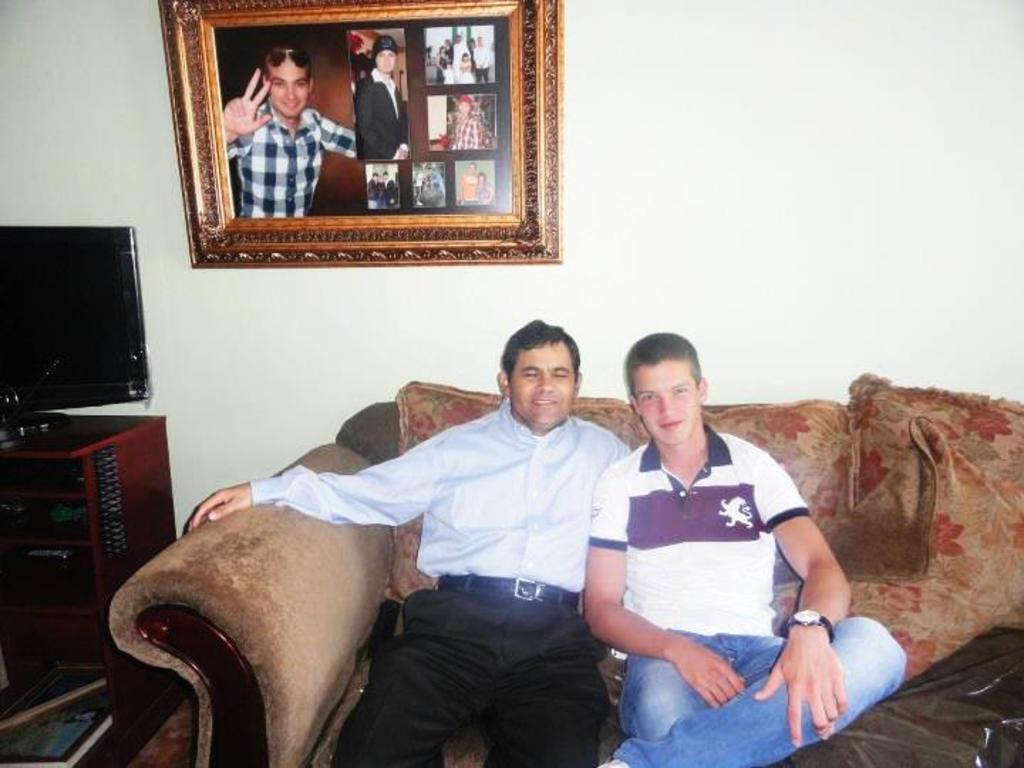What are the men in the image doing? The men in the image are sitting on the sofa. What can be seen on the table in the image? There is a television on a table in the image. What is on the other table in the image? There is a book on another table in the image. What is hanging on the wall in the image? There is a photo frame on the wall in the image. How many letters are visible on the book in the image? There is no information about the content of the book or the presence of letters on it in the provided facts. 